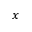<formula> <loc_0><loc_0><loc_500><loc_500>x</formula> 